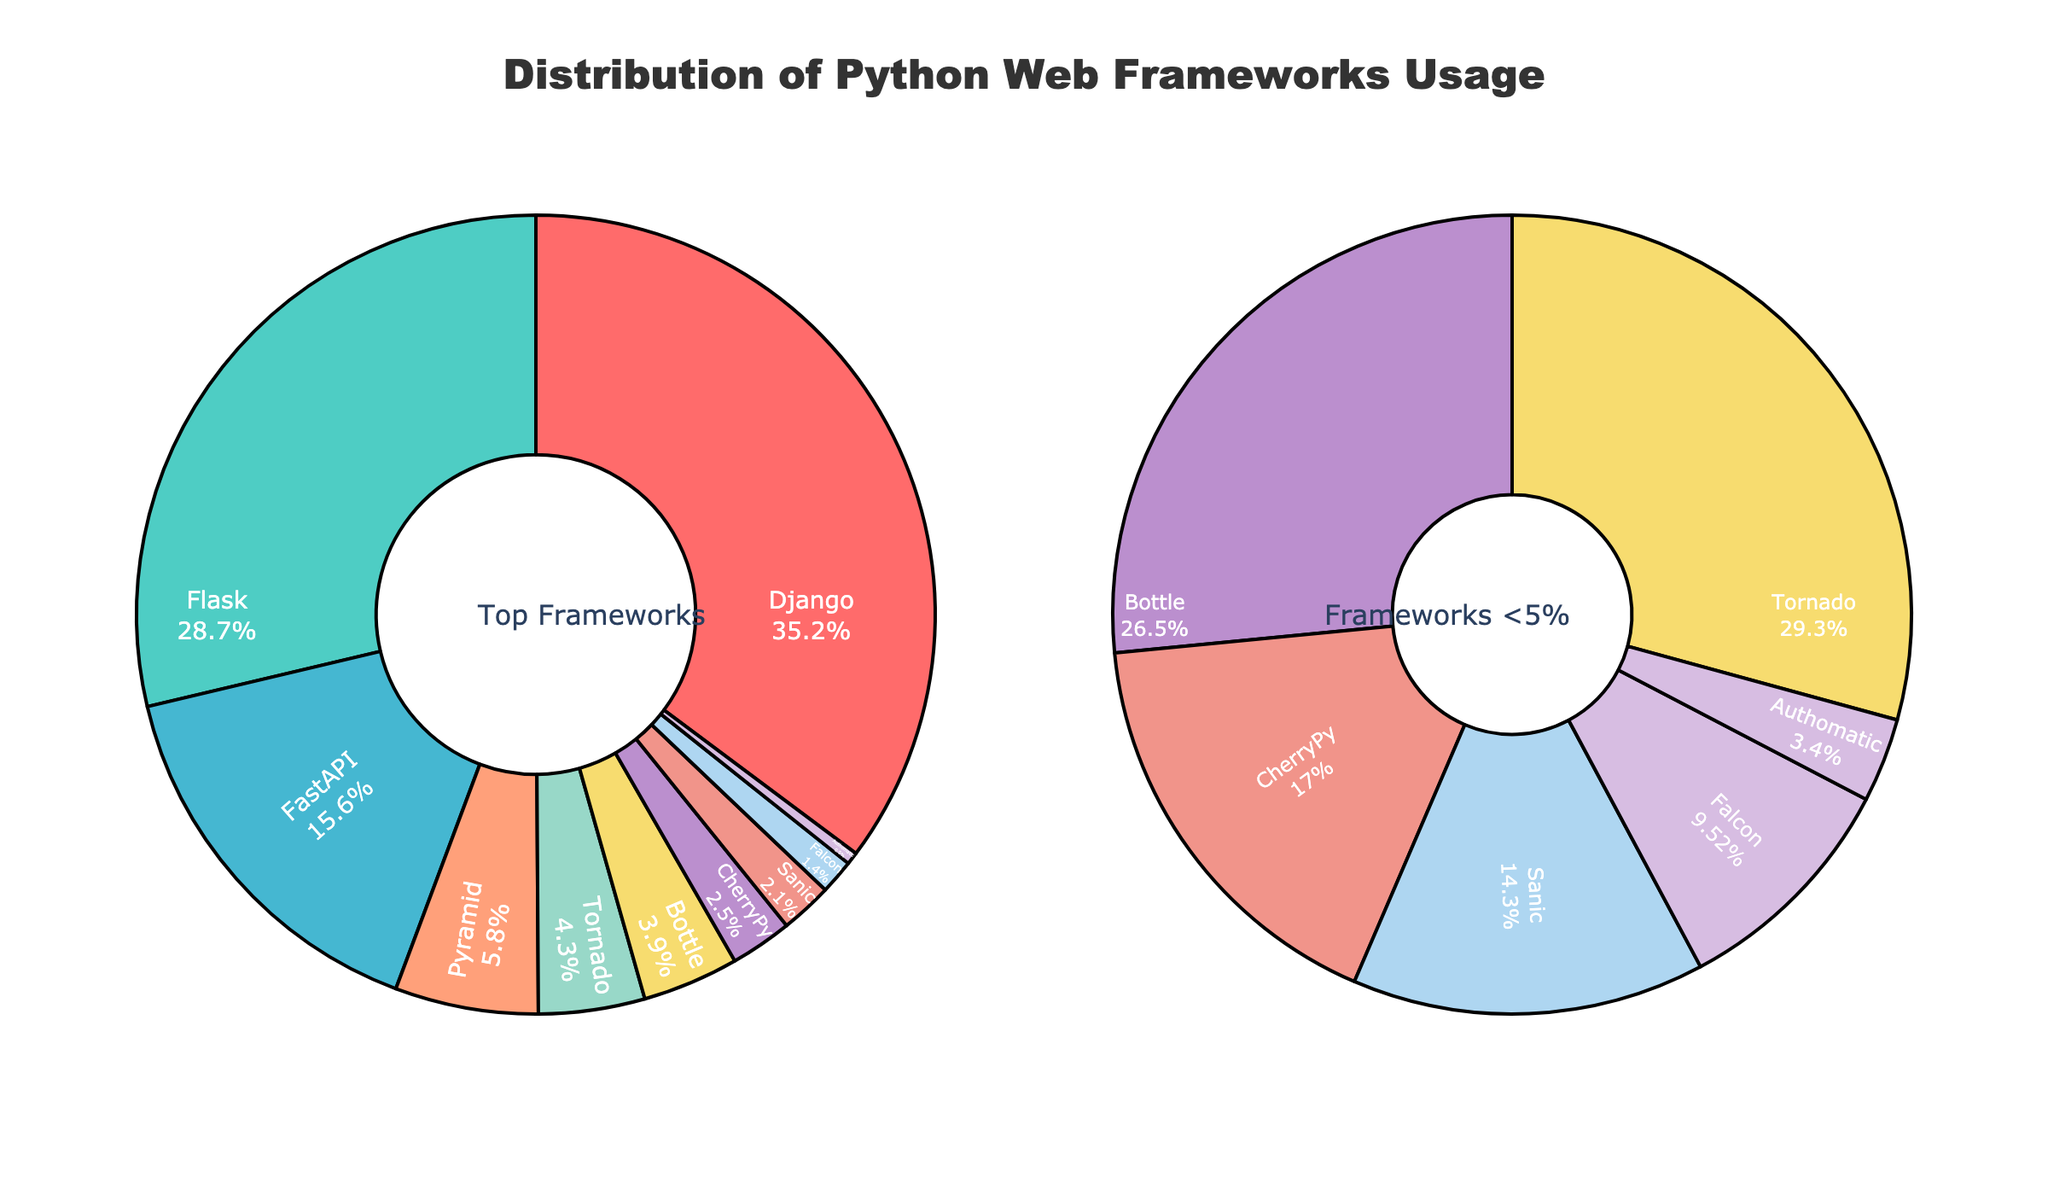What's the most popular Python web framework among developers? The pie chart shows the Distribution of Python Web Frameworks Usage, and the framework with the largest section represents the most popular one. Django has the largest section with 35.2%.
Answer: Django What's the total percentage of usage for frameworks with less than 5% usage? To determine this, we refer to the secondary pie chart showing frameworks with less than 5% usage. Summing the percentages for Pyramid (5.8 isn't less than 5), Tornado (4.3), Bottle (3.9), CherryPy (2.5), Sanic (2.1), Falcon (1.4), and Authomatic (0.5) gives 14.7.
Answer: 14.7% Which framework has slightly less usage than FastAPI? The pie chart shows the usage percentages. Comparing the frameworks, FastAPI has 15.6% usage, and the framework directly below it is Pyramid with 5.8%.
Answer: Pyramid How much more popular is Django compared to Flask? The pie chart provides the percentages directly. Django is at 35.2%, and Flask is at 28.7%. The difference is 35.2% - 28.7% = 6.5%.
Answer: 6.5% Which framework has the smallest usage? The pie chart lists the distribution of usage across the frameworks. The framework with the smallest section is Authomatic at 0.5%.
Answer: Authomatic What is the combined percentage usage of Flask and FastAPI? Flask has a usage percentage of 28.7%, and FastAPI has 15.6%. Adding them together gives 28.7% + 15.6% = 44.3%.
Answer: 44.3% Is Tornado more popular than Bottle? By comparing their positions on the main pie chart, Tornado has 4.3% while Bottle has 3.9%, making Tornado slightly more popular.
Answer: Yes What is the average percentage usage of the frameworks with less than 5% usage? From the secondary pie chart, the frameworks with less than 5% usage are Tornado (4.3%), Bottle (3.9%), CherryPy (2.5%), Sanic (2.1%), Falcon (1.4%), and Authomatic (0.5%). To find the average: (4.3 + 3.9 + 2.5 + 2.1 + 1.4 + 0.5) / 6 = 14.7 / 6 = 2.45.
Answer: 2.45% Is the usage of Pyramid more than double that of CherryPy? Pyramid has a usage percentage of 5.8%, while CherryPy has 2.5%. Double CherryPy's usage is 2.5% * 2 = 5%, which is less than Pyramid's 5.8%.
Answer: Yes Which frameworks together account for just above 50% of the usage? By adding the major contributions, Django (35.2%) and Flask (28.7%) together total 63.9%. We need to find the combination around 50%. Combining Django (35.2%) with most of FastAPI (15.6%) gives around 50.8%.
Answer: Django and Flask 